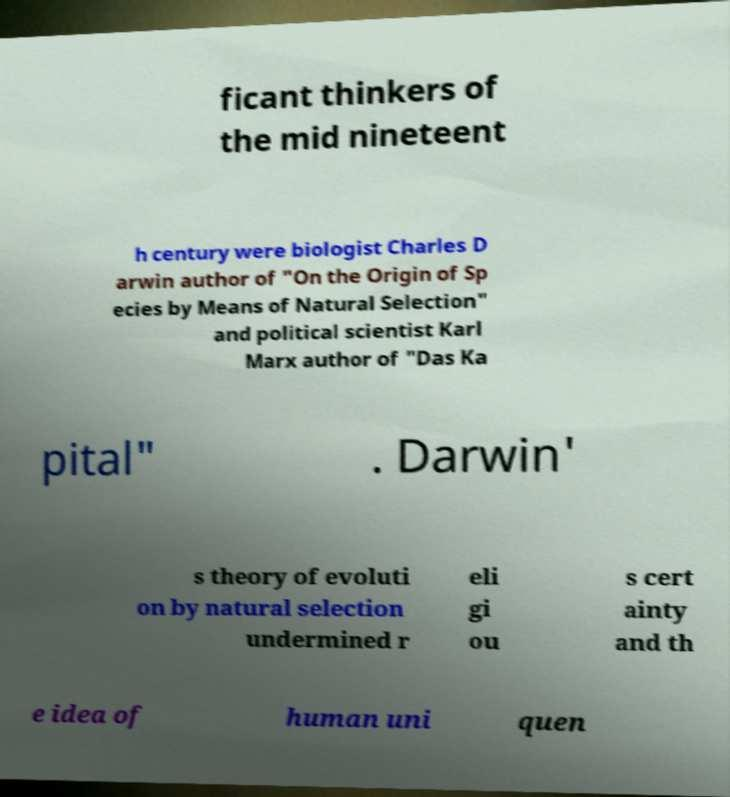Could you extract and type out the text from this image? ficant thinkers of the mid nineteent h century were biologist Charles D arwin author of "On the Origin of Sp ecies by Means of Natural Selection" and political scientist Karl Marx author of "Das Ka pital" . Darwin' s theory of evoluti on by natural selection undermined r eli gi ou s cert ainty and th e idea of human uni quen 